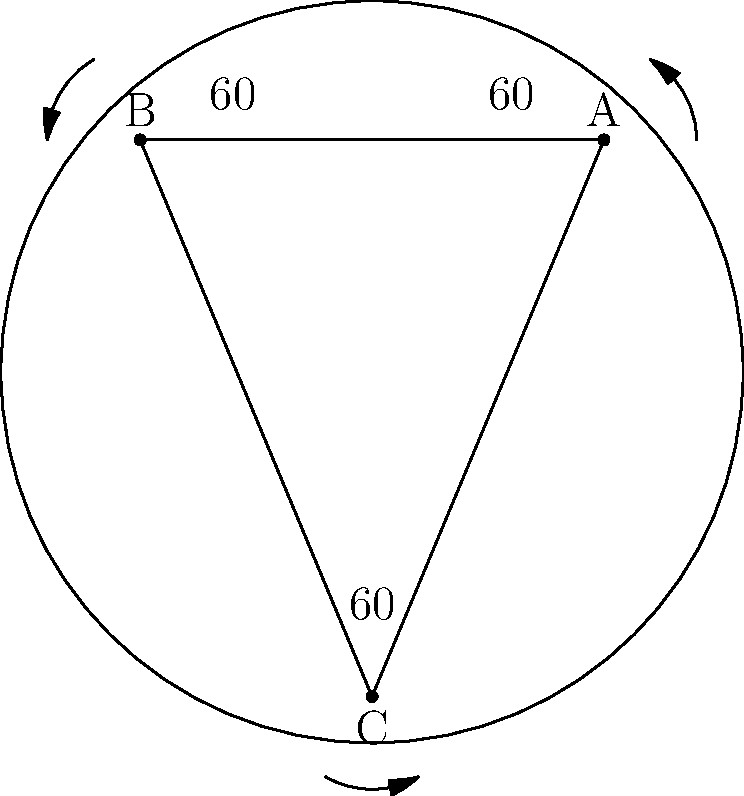In this simplified representation of a tiger's coat pattern, three distinct fur patterns meet at points A, B, and C, forming a triangle. If the angles between these patterns at each point are equal, what is the measure of each angle? To solve this problem, let's follow these steps:

1. Observe that the fur patterns form a triangle ABC on the tiger's coat.

2. Recall that the sum of angles in any triangle is always 180°.

3. We're told that the angles between the patterns at each point (A, B, and C) are equal.

4. Let's call the measure of each of these angles $x°$.

5. Since there are three equal angles in the triangle, we can set up the equation:

   $x° + x° + x° = 180°$

6. Simplify the equation:

   $3x° = 180°$

7. Solve for $x$:

   $x = 180° ÷ 3 = 60°$

Therefore, each angle between the fur patterns measures 60°.
Answer: 60° 